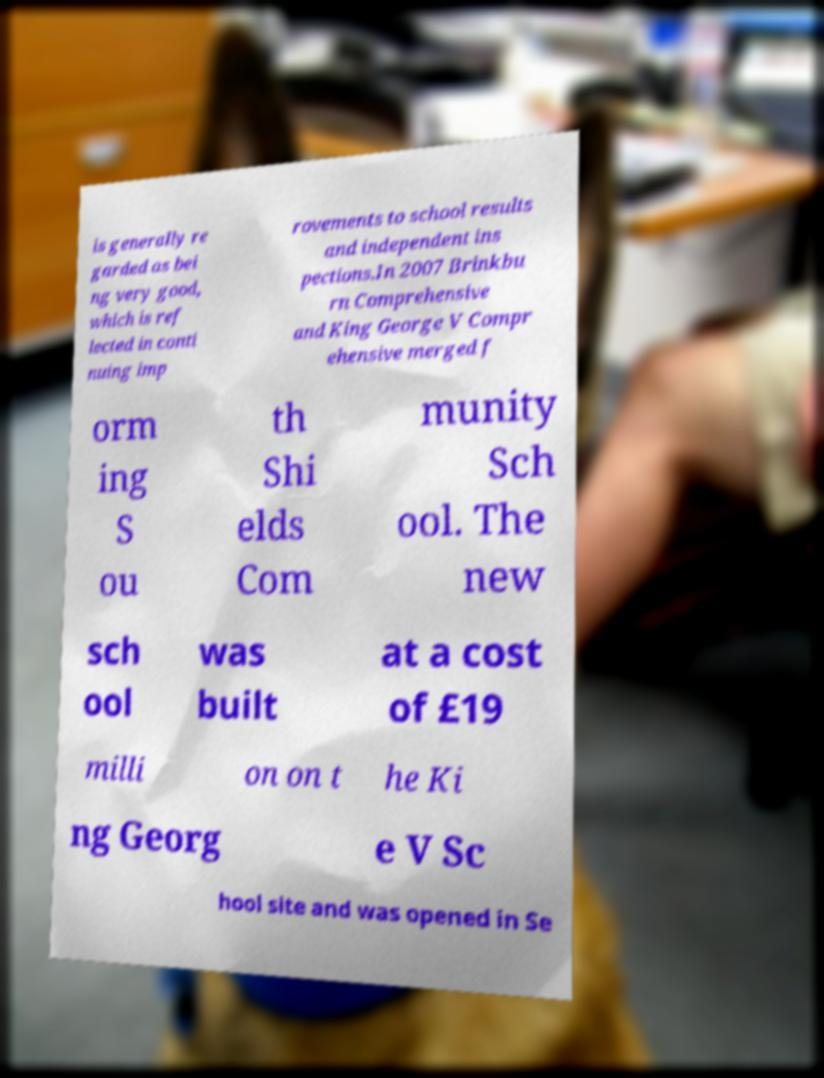Can you read and provide the text displayed in the image?This photo seems to have some interesting text. Can you extract and type it out for me? is generally re garded as bei ng very good, which is ref lected in conti nuing imp rovements to school results and independent ins pections.In 2007 Brinkbu rn Comprehensive and King George V Compr ehensive merged f orm ing S ou th Shi elds Com munity Sch ool. The new sch ool was built at a cost of £19 milli on on t he Ki ng Georg e V Sc hool site and was opened in Se 